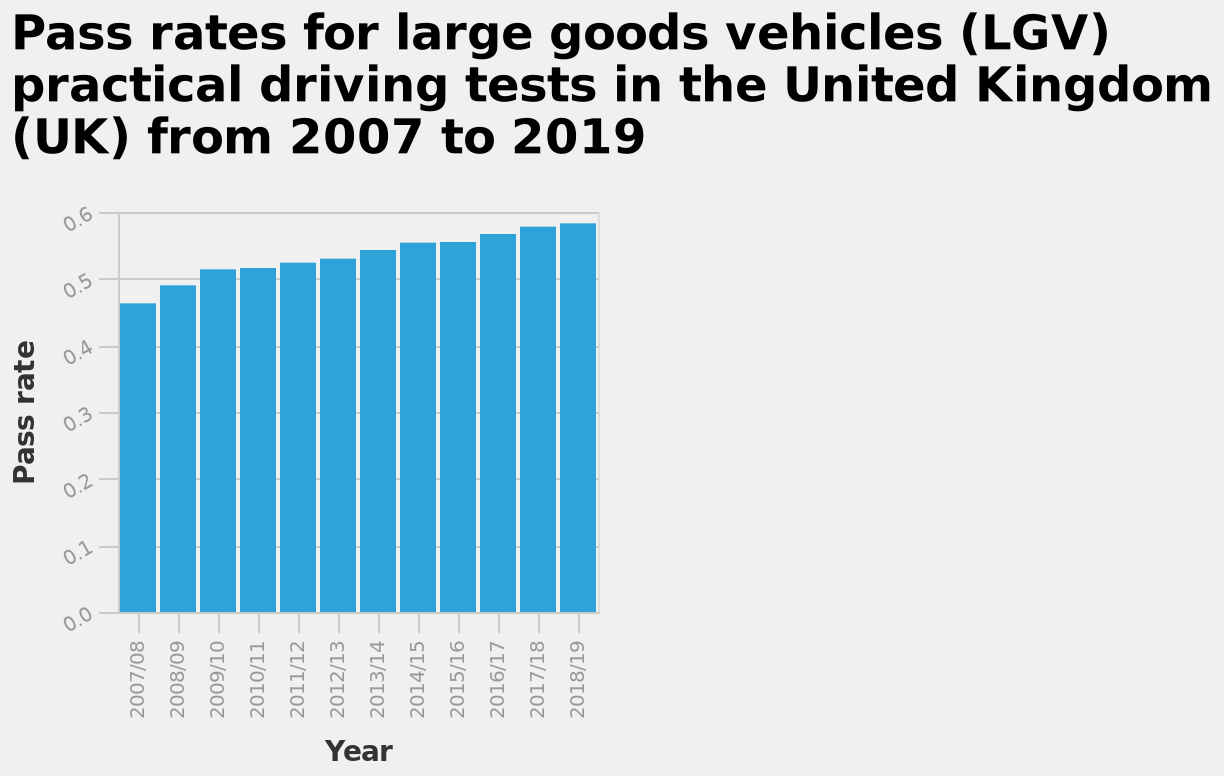<image>
What is being represented by the bar heights in the diagram? The heights of the bars in the diagram represent the pass rates for large goods vehicles (LGV) practical driving tests in the United Kingdom. What is the y-axis of the bar diagram showing? The y-axis of the bar diagram shows the pass rate for large goods vehicles (LGV) practical driving tests in the United Kingdom. Has the pass rate experienced any significant drops throughout the years?  The given information does not mention any significant drops in the pass rate. 